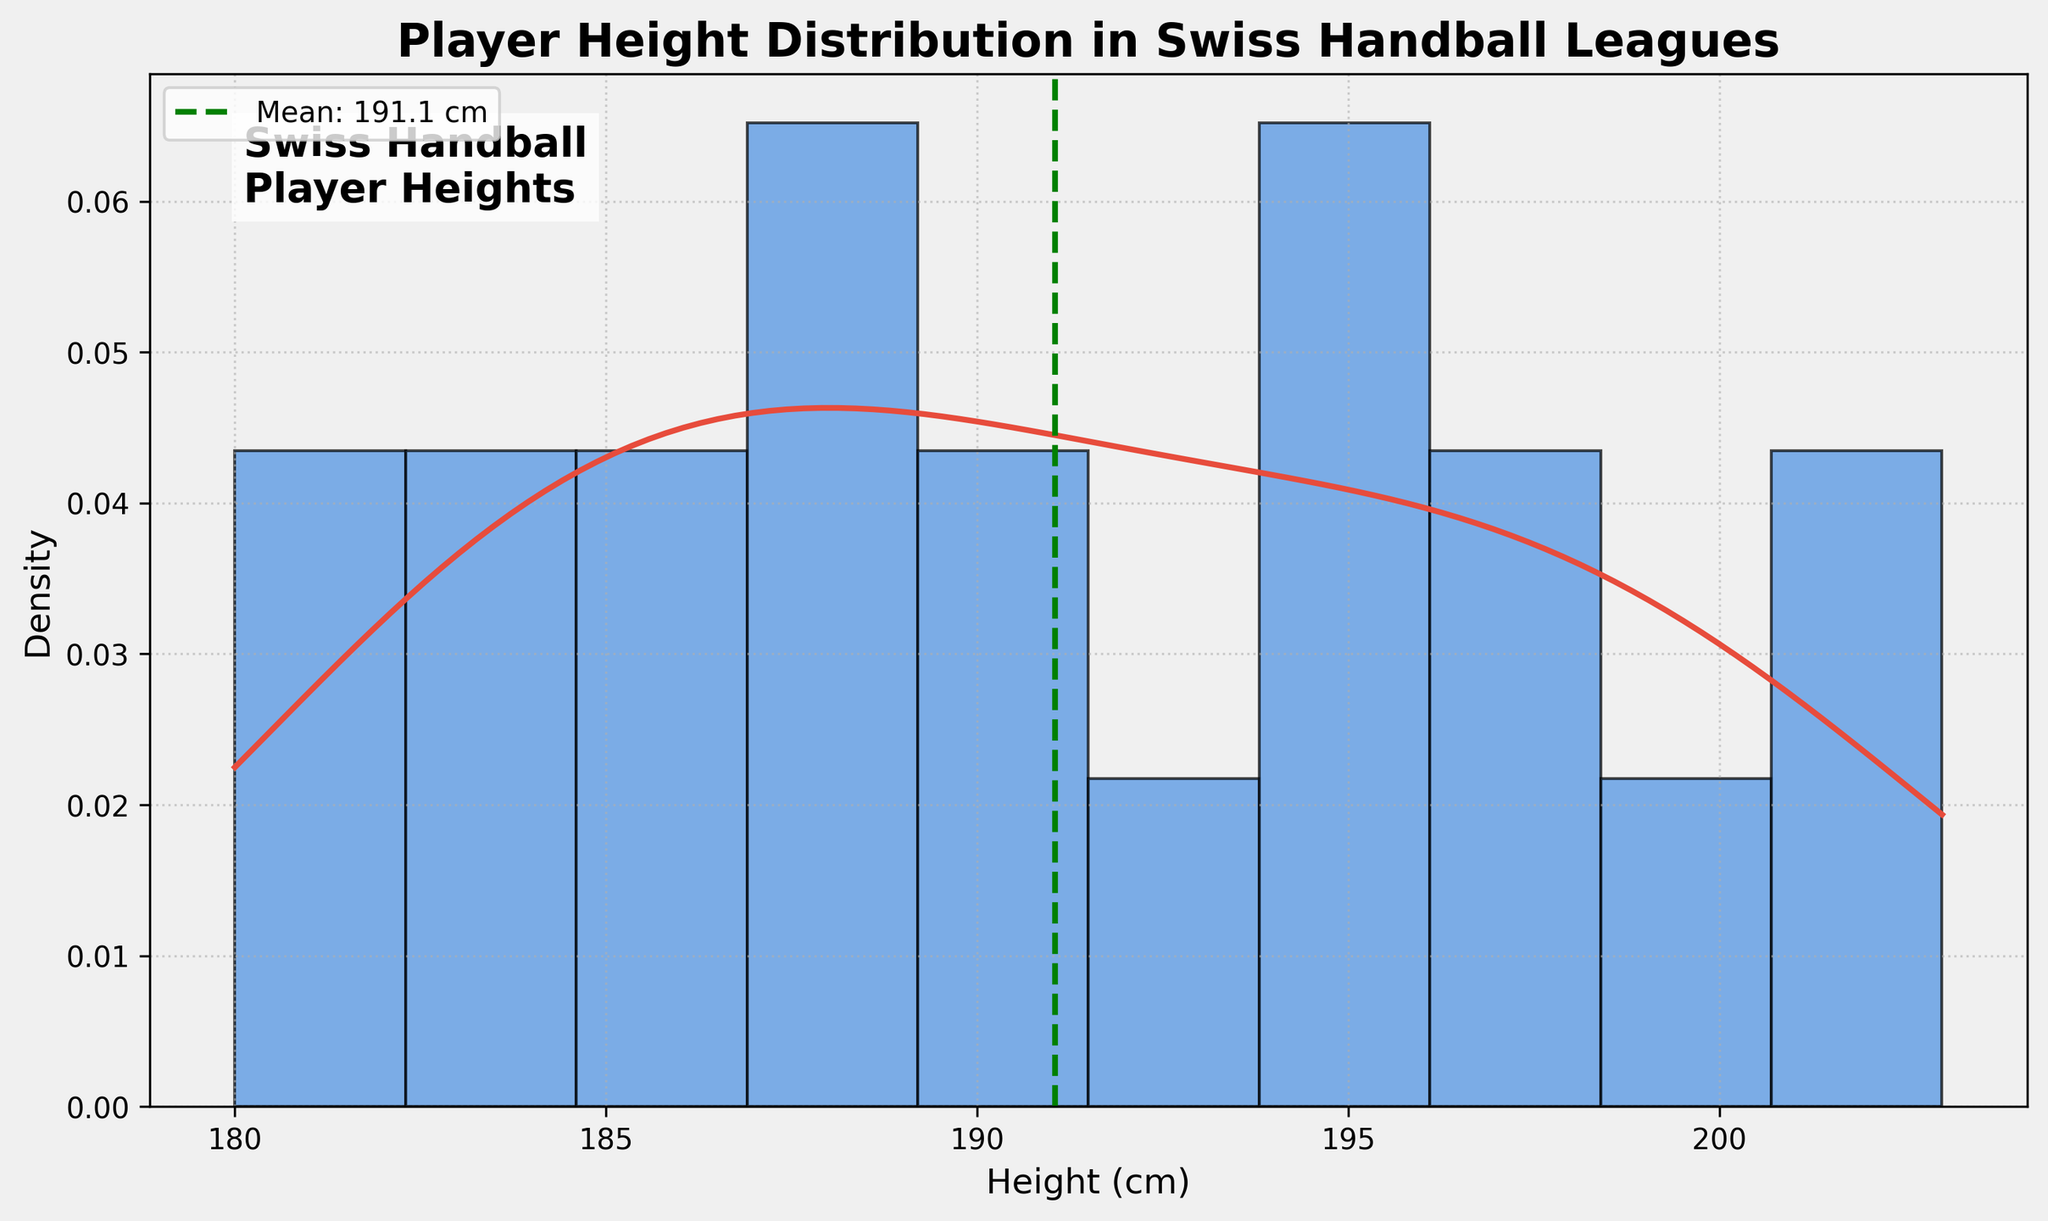How many bins are used in the histogram? The histogram visual shows 10 distinct bars representing the frequency distribution of heights. Each of these bars is a bin.
Answer: 10 What's the title of the plot? The title is located at the top of the plot, indicating the purpose of the visualization.
Answer: Player Height Distribution in Swiss Handball Leagues What is the mean height of the players? There is a dashed vertical line in green with a label that indicates the mean height of the players. The label reads "Mean: 191.1 cm."
Answer: 191.1 cm What's the tallest height shown in the histogram? The histogram bars terminate around the value "203" on the x-axis, representing the tallest player.
Answer: 203 cm Which height range appears to be the most frequent among the players? The tallest bar in the histogram indicates this, which is around the 185 to 190 cm range. The height of the bar is highest in this section, showing that more players fall within this group.
Answer: 185-190 cm Is the player height distribution skewed, and if so, in which direction? Based on the histogram and KDE curve, the distribution has a longer tail on the right, suggesting it is positively skewed.
Answer: Positively skewed What is the height range for the KDE curve? The KDE curve spans the x-axis horizontally from the minimum to the maximum player heights. It starts from the minimum height of around 180 cm to the maximum height of 203 cm.
Answer: 180-203 cm Compare the number of players with heights less than the mean to those with heights greater than the mean. The dashed line indicates the mean height at 191.1 cm. By examining the histogram bars to the left (lesser heights) and to the right (greater heights) of this line, one can visually estimate the comparability. There are more taller bars to the right of the mean, suggesting more players are taller than 191.1 cm.
Answer: More players are taller than the mean What's the range of the shortest player's height to the average height? The shortest player's height is 180 cm and the mean height is 191.1 cm. The range is calculated by subtracting the shortest height from the mean.
Answer: 11.1 cm How does the KDE curve help in understanding the distribution compared to the histogram? The KDE curve smoothens the data distribution, providing a continuous probability density estimate, indicating where player heights are concentrated more precisely compared to the discrete bars of the histogram.
Answer: It provides a smooth density estimate 